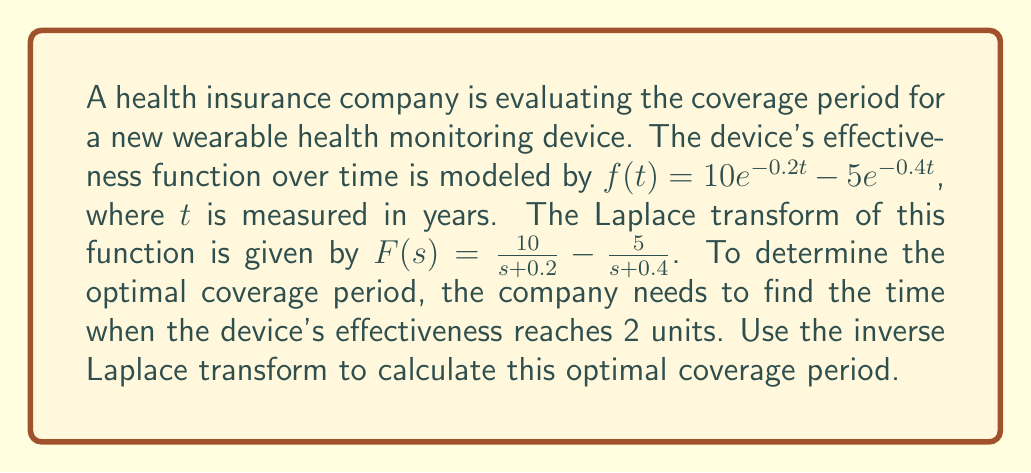What is the answer to this math problem? To solve this problem, we'll follow these steps:

1) We need to find $t$ when $f(t) = 2$. This means we need to solve the equation:
   $$10e^{-0.2t} - 5e^{-0.4t} = 2$$

2) To use the inverse Laplace transform, we need to transform this equation into the s-domain:
   $$F(s) - \frac{2}{s} = 0$$

3) Substituting the given $F(s)$:
   $$\frac{10}{s+0.2} - \frac{5}{s+0.4} - \frac{2}{s} = 0$$

4) Finding a common denominator:
   $$\frac{10s(s+0.4) - 5s(s+0.2) - 2(s+0.2)(s+0.4)}{s(s+0.2)(s+0.4)} = 0$$

5) Expanding the numerator:
   $$\frac{10s^2 + 4s - 5s^2 - s - 2s^2 - 1.2s - 0.16}{s(s+0.2)(s+0.4)} = 0$$

6) Simplifying:
   $$\frac{3s^2 + 2.8s - 0.16}{s(s+0.2)(s+0.4)} = 0$$

7) The roots of the numerator will give us the solution in the s-domain. Using the quadratic formula:
   $$s = \frac{-2.8 \pm \sqrt{2.8^2 + 4(3)(0.16)}}{2(3)} = -0.4 \text{ or } -0.133$$

8) The solution $s = -0.4$ is extraneous as it cancels with a term in the denominator. Therefore, our solution is $s = -0.133$.

9) To find $t$, we use the property that if $F(s) = \frac{1}{s+a}$, then $f(t) = e^{-at}$. Therefore:
   $$t = -\frac{\ln(2)}{0.133} \approx 5.21 \text{ years}$$
Answer: The optimal coverage period for the health monitoring device is approximately 5.21 years. 